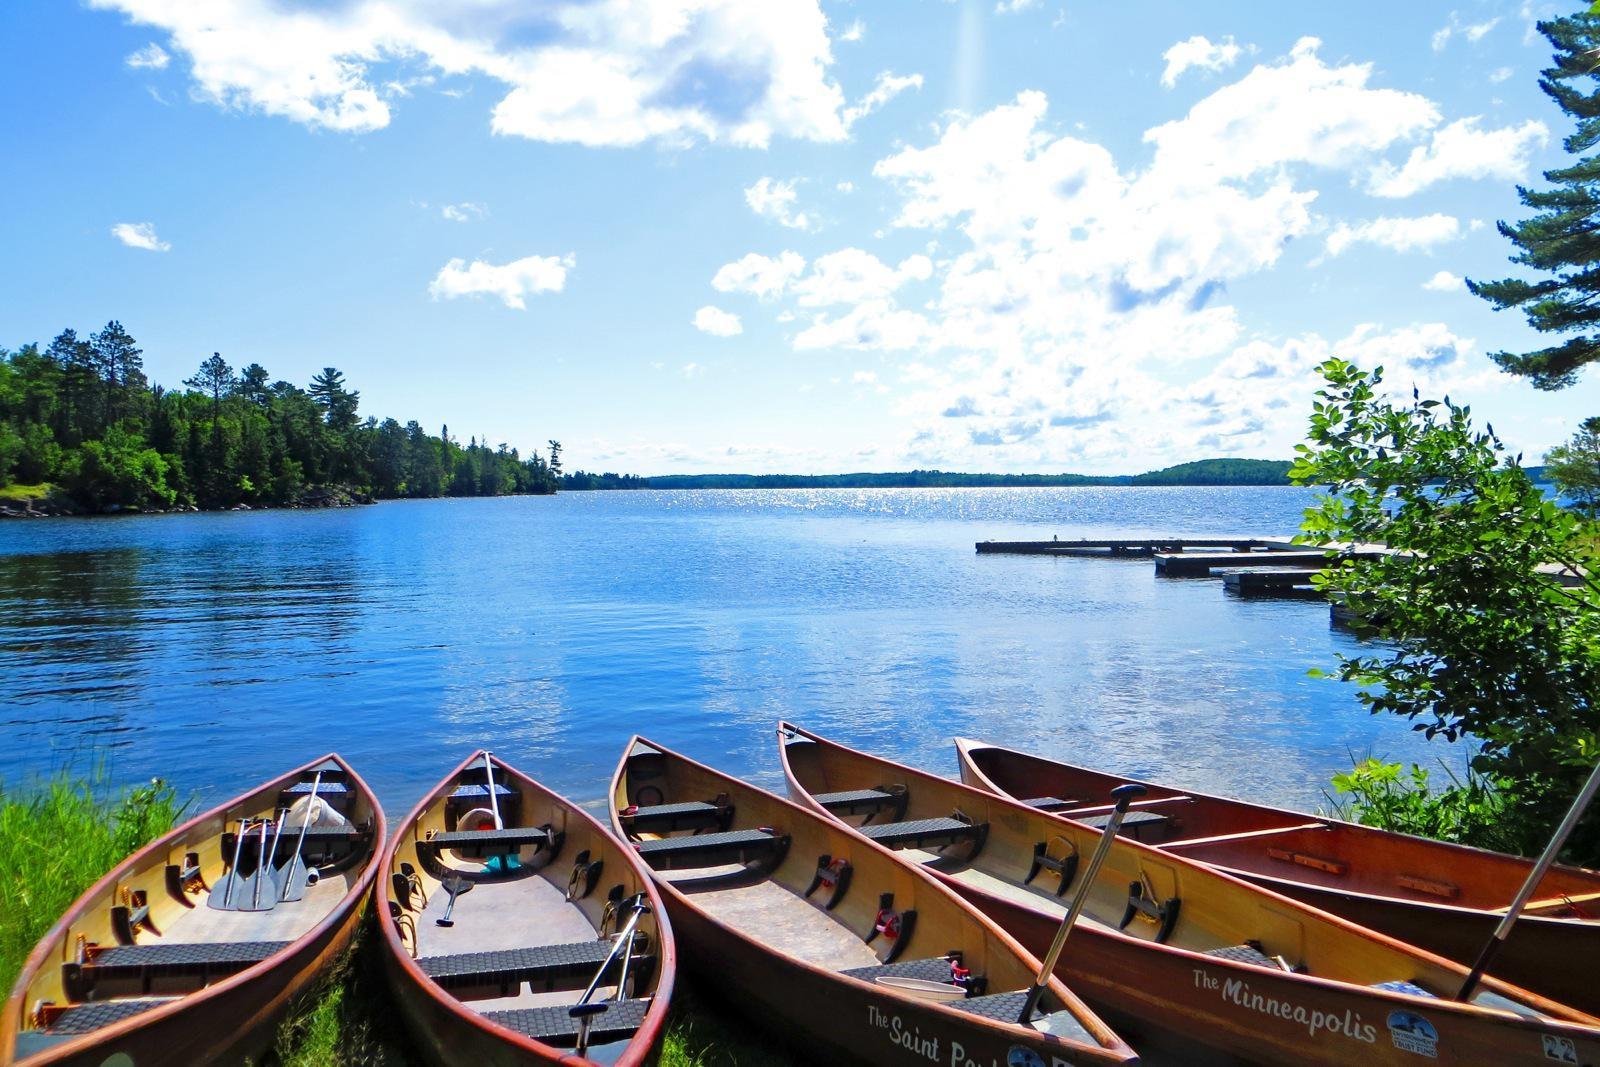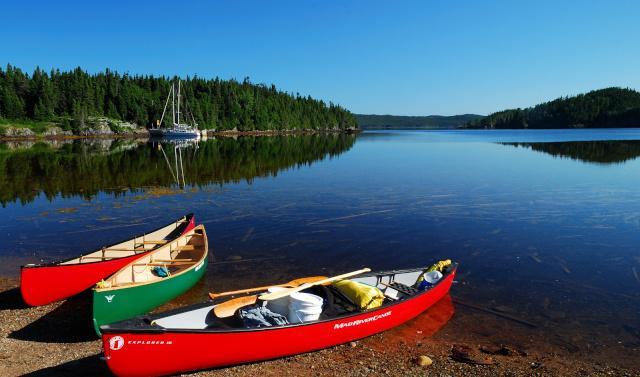The first image is the image on the left, the second image is the image on the right. Assess this claim about the two images: "In at least one image, canoes are docked at the water edge with no people present.". Correct or not? Answer yes or no. Yes. 